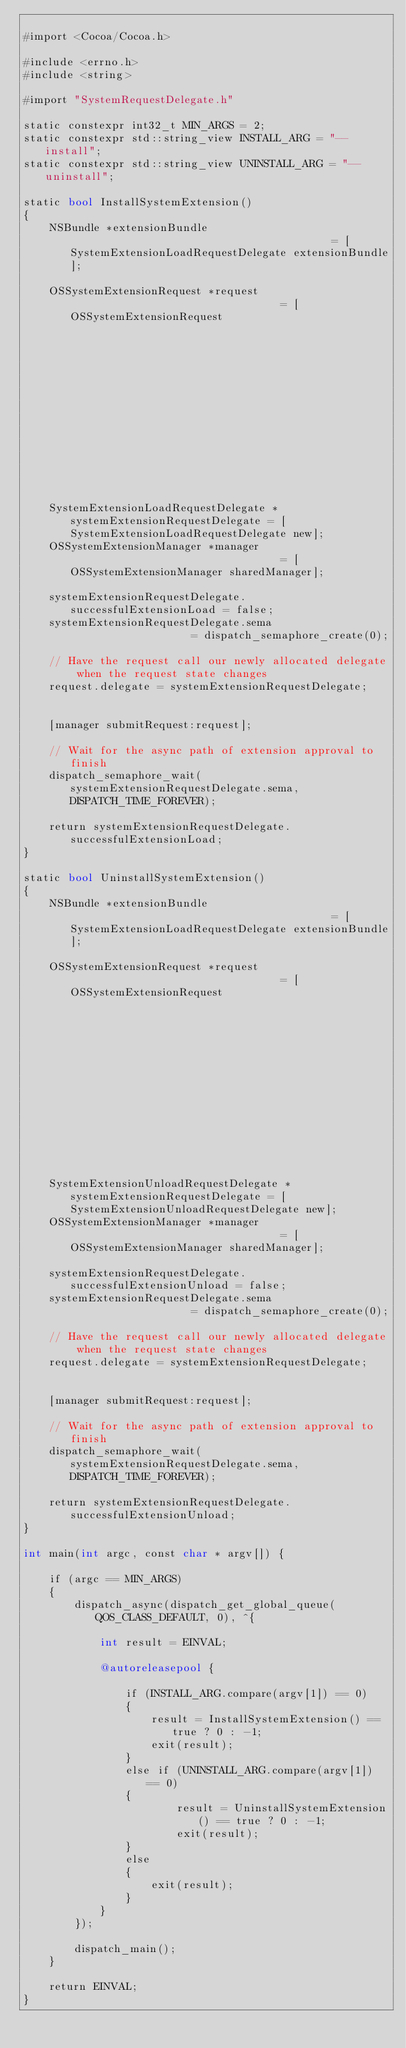Convert code to text. <code><loc_0><loc_0><loc_500><loc_500><_ObjectiveC_>
#import <Cocoa/Cocoa.h>

#include <errno.h>
#include <string>

#import "SystemRequestDelegate.h"

static constexpr int32_t MIN_ARGS = 2;
static constexpr std::string_view INSTALL_ARG = "--install";
static constexpr std::string_view UNINSTALL_ARG = "--uninstall";

static bool InstallSystemExtension()
{
    NSBundle *extensionBundle                                          = [SystemExtensionLoadRequestDelegate extensionBundle];
    
    OSSystemExtensionRequest *request                                  = [OSSystemExtensionRequest
                                                                          activationRequestForExtension:[extensionBundle bundleIdentifier]
                                                                          queue:dispatch_get_main_queue()];
    
    SystemExtensionLoadRequestDelegate *systemExtensionRequestDelegate = [SystemExtensionLoadRequestDelegate new];
    OSSystemExtensionManager *manager                                  = [OSSystemExtensionManager sharedManager];
    
    systemExtensionRequestDelegate.successfulExtensionLoad = false;
    systemExtensionRequestDelegate.sema                    = dispatch_semaphore_create(0);
    
    // Have the request call our newly allocated delegate when the request state changes
    request.delegate = systemExtensionRequestDelegate;
    
    
    [manager submitRequest:request];
    
    // Wait for the async path of extension approval to finish
    dispatch_semaphore_wait(systemExtensionRequestDelegate.sema, DISPATCH_TIME_FOREVER);
    
    return systemExtensionRequestDelegate.successfulExtensionLoad;
}

static bool UninstallSystemExtension()
{
    NSBundle *extensionBundle                                          = [SystemExtensionLoadRequestDelegate extensionBundle];
    
    OSSystemExtensionRequest *request                                  = [OSSystemExtensionRequest
                                                                          deactivationRequestForExtension:[extensionBundle bundleIdentifier]
                                                                          queue:dispatch_get_main_queue()];
    
    SystemExtensionUnloadRequestDelegate *systemExtensionRequestDelegate = [SystemExtensionUnloadRequestDelegate new];
    OSSystemExtensionManager *manager                                  = [OSSystemExtensionManager sharedManager];
    
    systemExtensionRequestDelegate.successfulExtensionUnload = false;
    systemExtensionRequestDelegate.sema                    = dispatch_semaphore_create(0);
    
    // Have the request call our newly allocated delegate when the request state changes
    request.delegate = systemExtensionRequestDelegate;
    
    
    [manager submitRequest:request];
    
    // Wait for the async path of extension approval to finish
    dispatch_semaphore_wait(systemExtensionRequestDelegate.sema, DISPATCH_TIME_FOREVER);
    
    return systemExtensionRequestDelegate.successfulExtensionUnload;
}

int main(int argc, const char * argv[]) {
    
    if (argc == MIN_ARGS)
    {
        dispatch_async(dispatch_get_global_queue(QOS_CLASS_DEFAULT, 0), ^{
            
            int result = EINVAL;
            
            @autoreleasepool {
                
                if (INSTALL_ARG.compare(argv[1]) == 0)
                {
                    result = InstallSystemExtension() == true ? 0 : -1;
                    exit(result);
                }
                else if (UNINSTALL_ARG.compare(argv[1]) == 0)
                {
                        result = UninstallSystemExtension() == true ? 0 : -1;
                        exit(result);
                }
                else
                {
                    exit(result);
                }
            }
        });
        
        dispatch_main();
    }
    
    return EINVAL;
}
</code> 